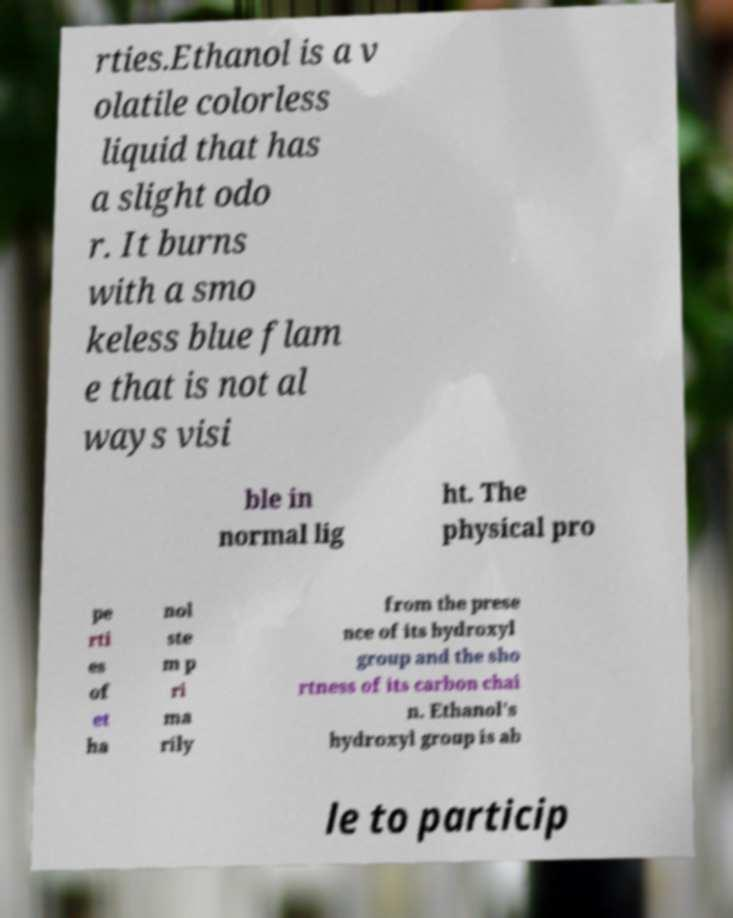Please identify and transcribe the text found in this image. rties.Ethanol is a v olatile colorless liquid that has a slight odo r. It burns with a smo keless blue flam e that is not al ways visi ble in normal lig ht. The physical pro pe rti es of et ha nol ste m p ri ma rily from the prese nce of its hydroxyl group and the sho rtness of its carbon chai n. Ethanol's hydroxyl group is ab le to particip 